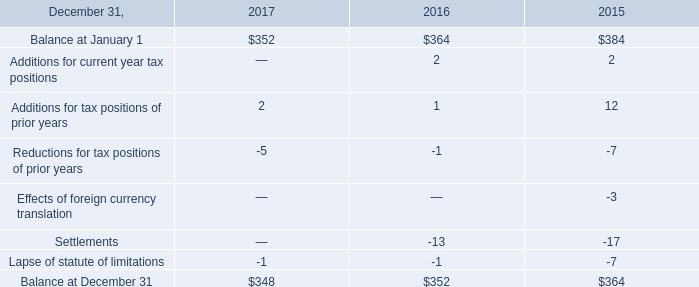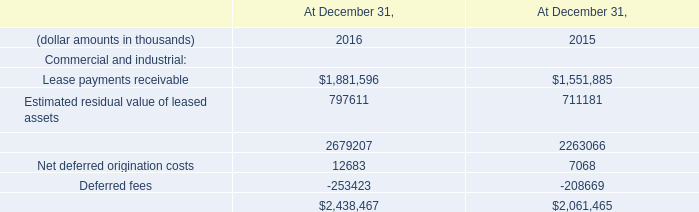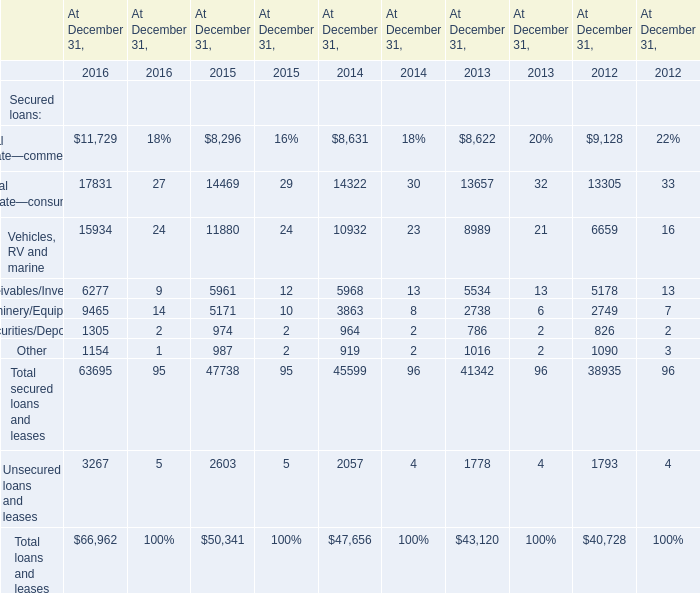what percent of the after-tax loss on deconsolidation hit ordinary income? 
Computations: (243 / 611)
Answer: 0.39771. 